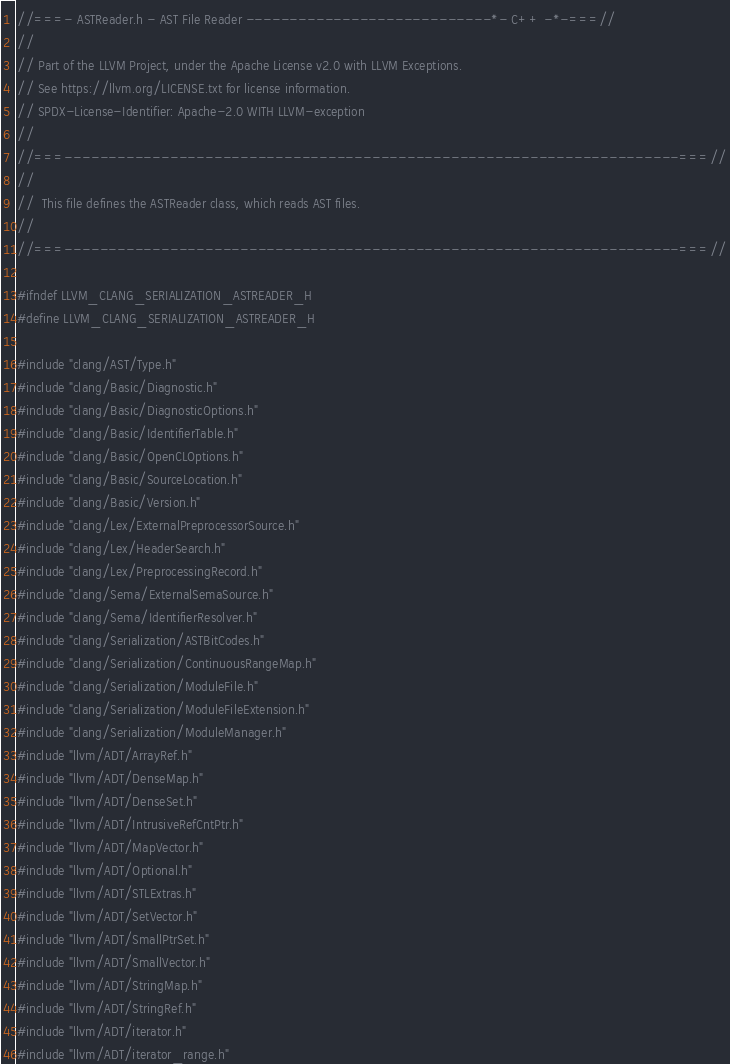Convert code to text. <code><loc_0><loc_0><loc_500><loc_500><_C_>//===- ASTReader.h - AST File Reader ----------------------------*- C++ -*-===//
//
// Part of the LLVM Project, under the Apache License v2.0 with LLVM Exceptions.
// See https://llvm.org/LICENSE.txt for license information.
// SPDX-License-Identifier: Apache-2.0 WITH LLVM-exception
//
//===----------------------------------------------------------------------===//
//
//  This file defines the ASTReader class, which reads AST files.
//
//===----------------------------------------------------------------------===//

#ifndef LLVM_CLANG_SERIALIZATION_ASTREADER_H
#define LLVM_CLANG_SERIALIZATION_ASTREADER_H

#include "clang/AST/Type.h"
#include "clang/Basic/Diagnostic.h"
#include "clang/Basic/DiagnosticOptions.h"
#include "clang/Basic/IdentifierTable.h"
#include "clang/Basic/OpenCLOptions.h"
#include "clang/Basic/SourceLocation.h"
#include "clang/Basic/Version.h"
#include "clang/Lex/ExternalPreprocessorSource.h"
#include "clang/Lex/HeaderSearch.h"
#include "clang/Lex/PreprocessingRecord.h"
#include "clang/Sema/ExternalSemaSource.h"
#include "clang/Sema/IdentifierResolver.h"
#include "clang/Serialization/ASTBitCodes.h"
#include "clang/Serialization/ContinuousRangeMap.h"
#include "clang/Serialization/ModuleFile.h"
#include "clang/Serialization/ModuleFileExtension.h"
#include "clang/Serialization/ModuleManager.h"
#include "llvm/ADT/ArrayRef.h"
#include "llvm/ADT/DenseMap.h"
#include "llvm/ADT/DenseSet.h"
#include "llvm/ADT/IntrusiveRefCntPtr.h"
#include "llvm/ADT/MapVector.h"
#include "llvm/ADT/Optional.h"
#include "llvm/ADT/STLExtras.h"
#include "llvm/ADT/SetVector.h"
#include "llvm/ADT/SmallPtrSet.h"
#include "llvm/ADT/SmallVector.h"
#include "llvm/ADT/StringMap.h"
#include "llvm/ADT/StringRef.h"
#include "llvm/ADT/iterator.h"
#include "llvm/ADT/iterator_range.h"</code> 